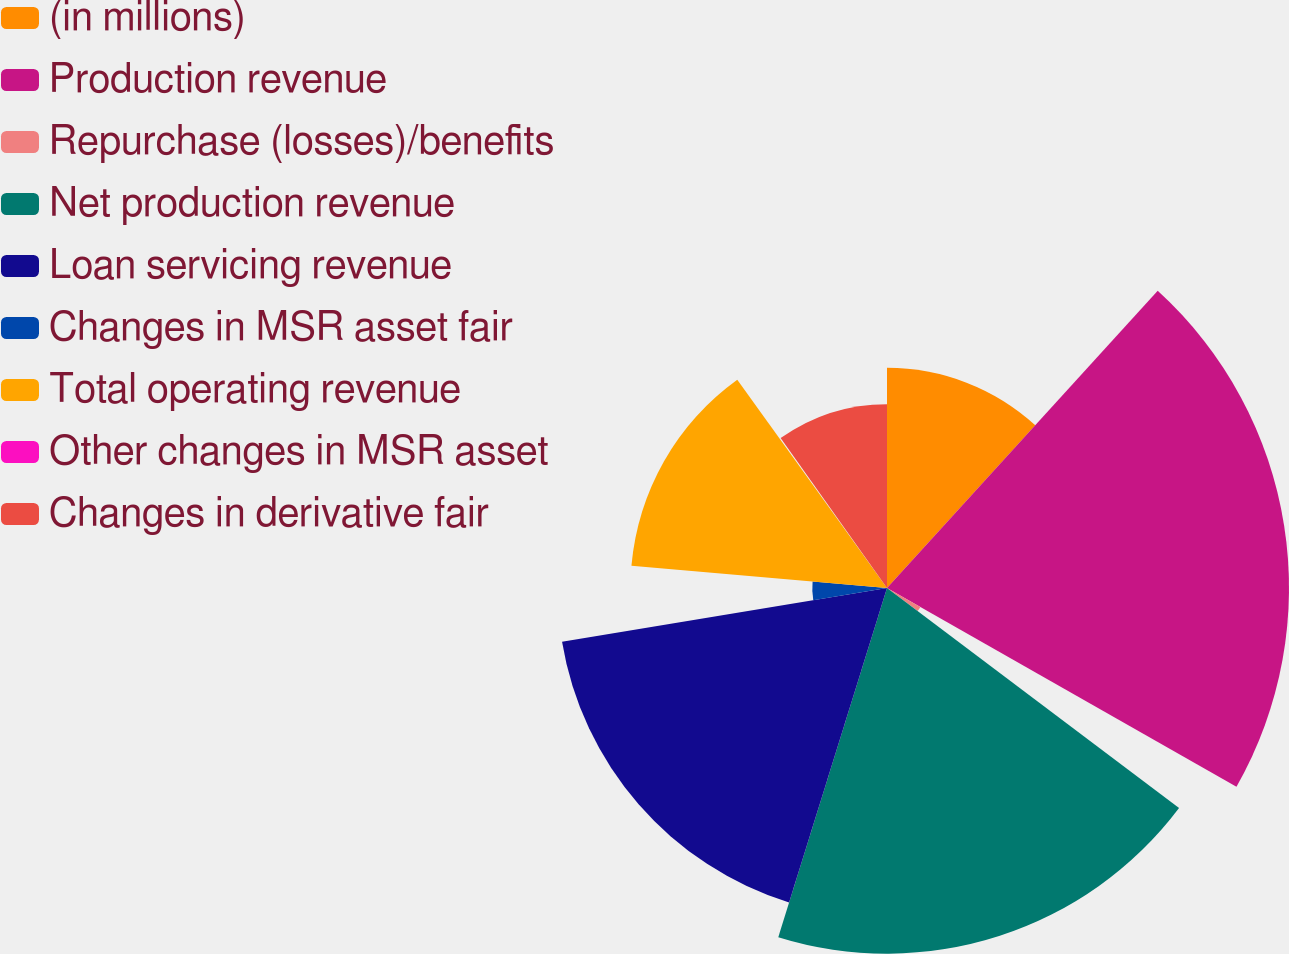<chart> <loc_0><loc_0><loc_500><loc_500><pie_chart><fcel>(in millions)<fcel>Production revenue<fcel>Repurchase (losses)/benefits<fcel>Net production revenue<fcel>Loan servicing revenue<fcel>Changes in MSR asset fair<fcel>Total operating revenue<fcel>Other changes in MSR asset<fcel>Changes in derivative fair<nl><fcel>11.76%<fcel>21.47%<fcel>2.05%<fcel>19.53%<fcel>17.59%<fcel>3.99%<fcel>13.7%<fcel>0.1%<fcel>9.82%<nl></chart> 